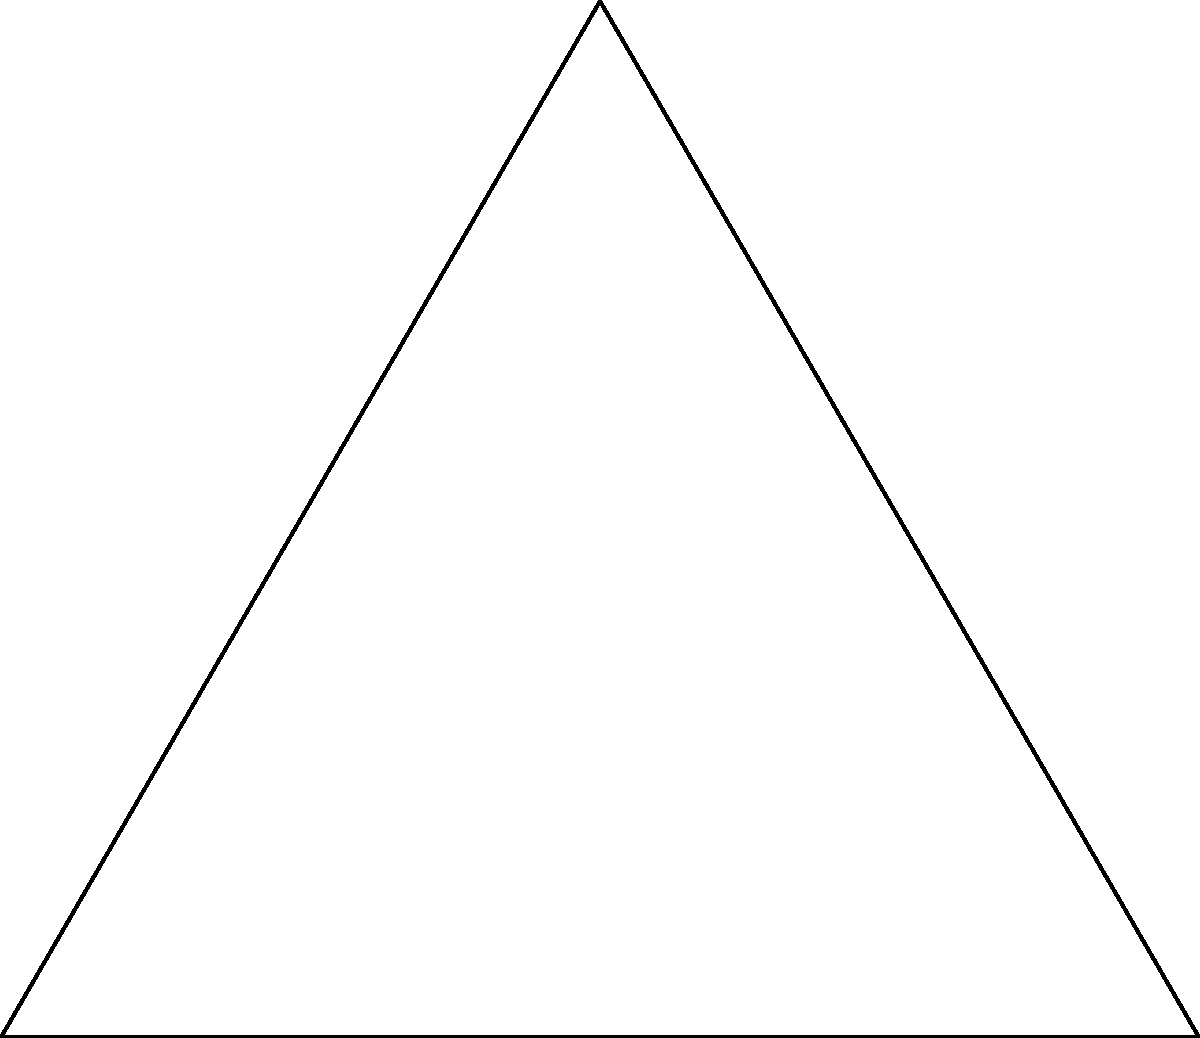As you design the perfect poker chip for your high-stakes online poker website, you decide to base its shape on an equilateral triangle inscribed in a circle. If the side length of the triangle is 4 cm, what is the radius $r$ of the circumscribed circle? Let's approach this step-by-step:

1) In an equilateral triangle, all sides are equal and all angles are 60°.

2) The radius of the circumscribed circle bisects the angle of the triangle, creating two 30-60-90 triangles.

3) In a 30-60-90 triangle, if the shortest side (opposite to 30°) is $x$, then the hypotenuse (opposite to 90°) is $2x$, and the remaining side (opposite to 60°) is $x\sqrt{3}$.

4) In our case, half of the side of the equilateral triangle is the hypotenuse of the 30-60-90 triangle. So:

   $2x = 4/2 = 2$
   $x = 1$

5) The radius of the circle is the longest side of this 30-60-90 triangle, which is $x\sqrt{3}$.

6) Therefore, $r = 1\sqrt{3} = \sqrt{3}$ cm.

7) To simplify: $\sqrt{3} \approx 1.732$ cm.
Answer: $r = \sqrt{3}$ cm or approximately 1.732 cm 